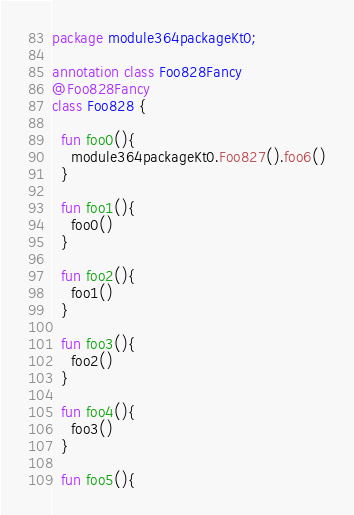Convert code to text. <code><loc_0><loc_0><loc_500><loc_500><_Kotlin_>package module364packageKt0;

annotation class Foo828Fancy
@Foo828Fancy
class Foo828 {

  fun foo0(){
    module364packageKt0.Foo827().foo6()
  }

  fun foo1(){
    foo0()
  }

  fun foo2(){
    foo1()
  }

  fun foo3(){
    foo2()
  }

  fun foo4(){
    foo3()
  }

  fun foo5(){</code> 